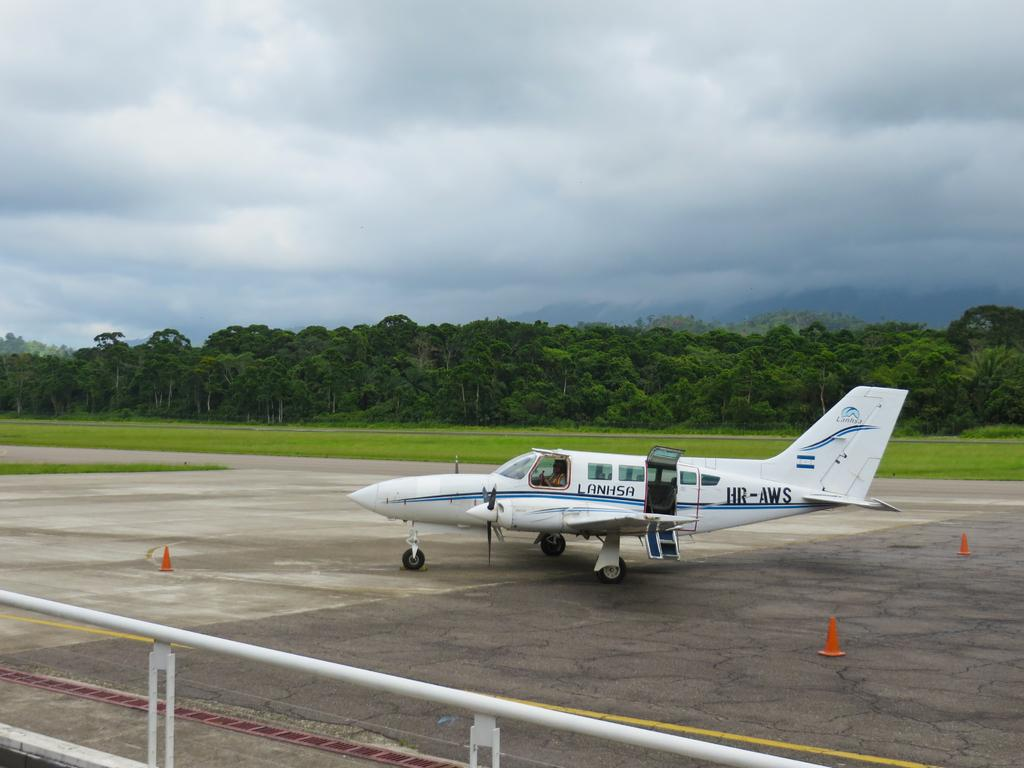<image>
Give a short and clear explanation of the subsequent image. An airplane is on the ground on a cloudy day with the word Lanhsa on it. 